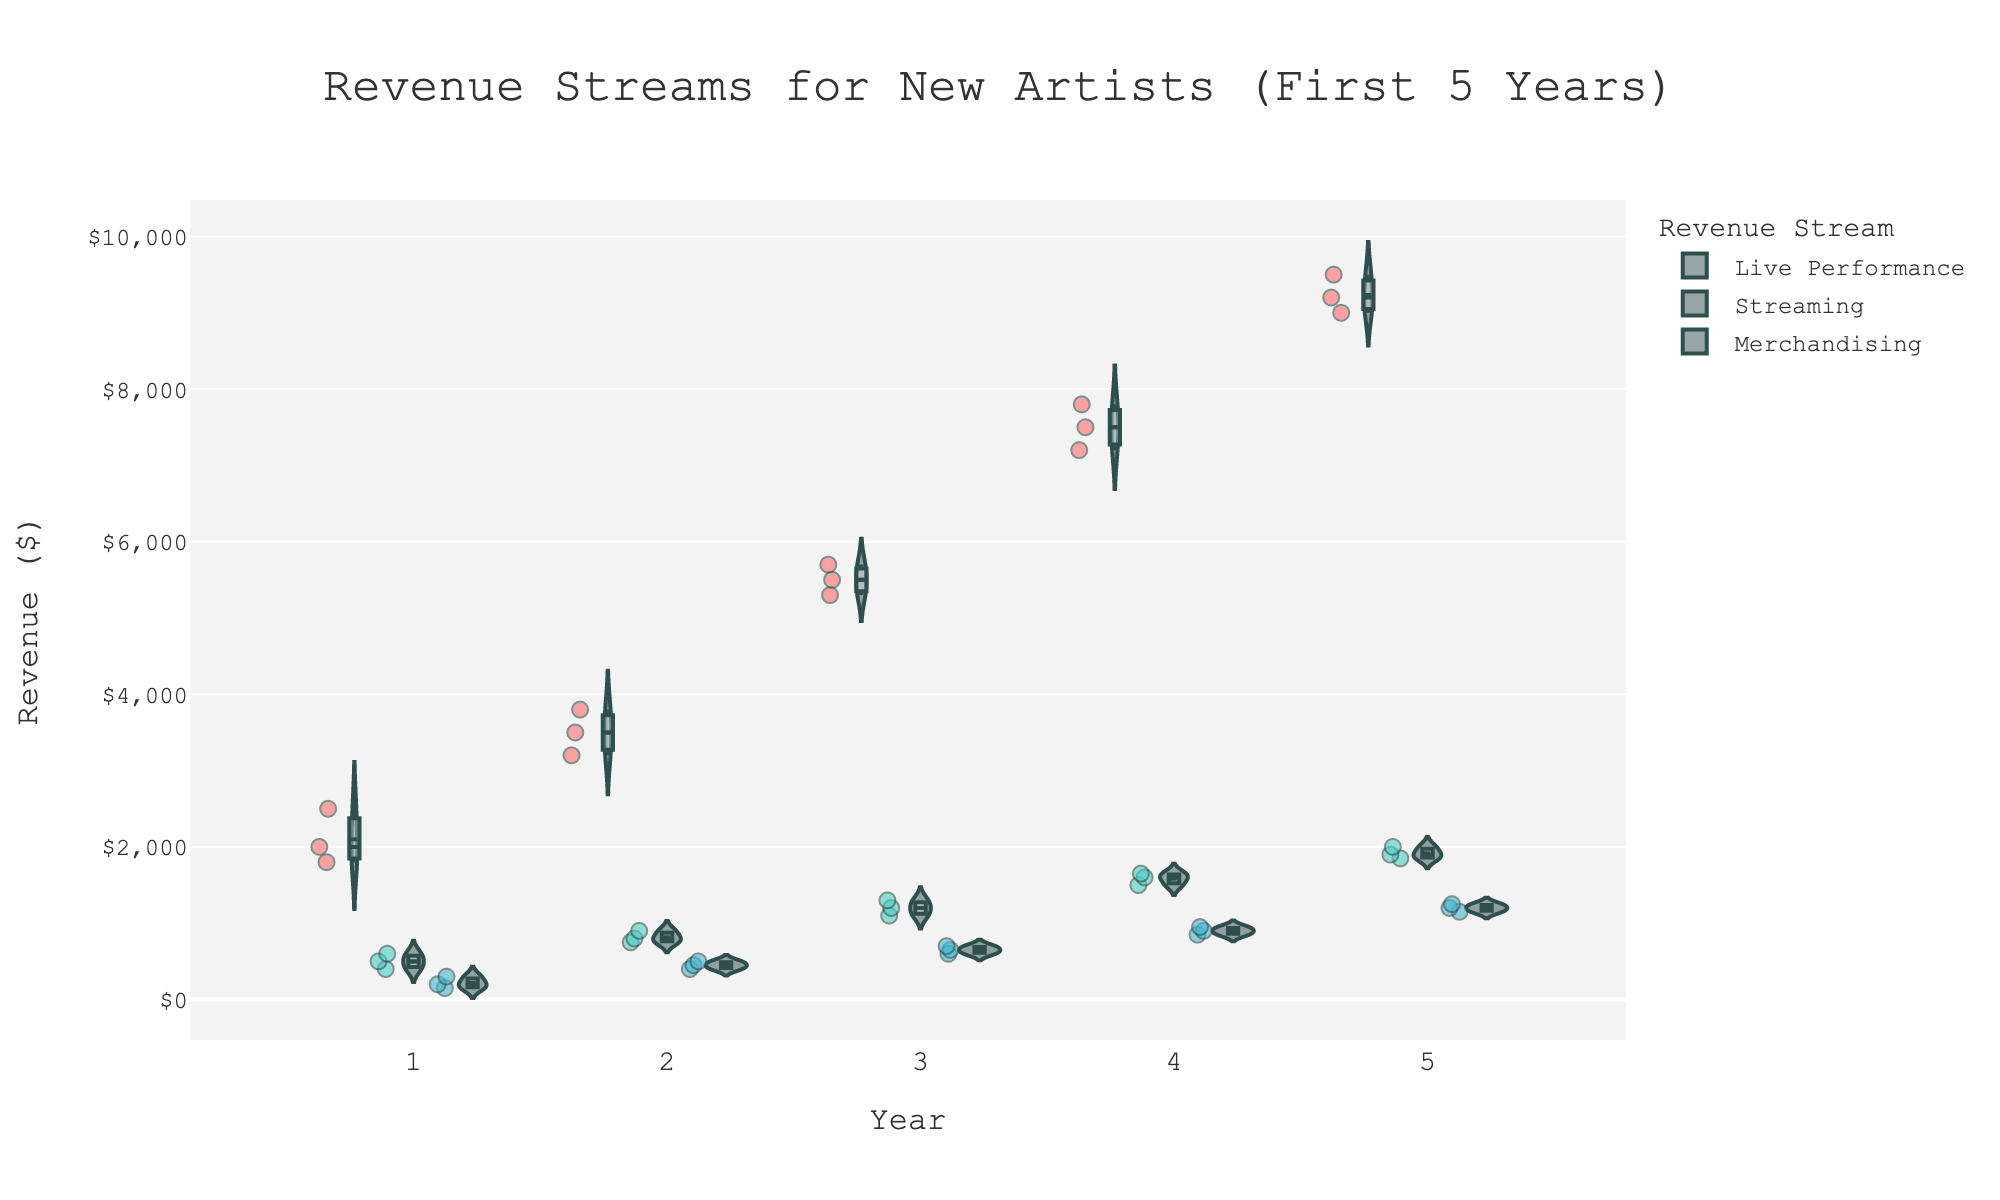What is the title of the figure? The title is located at the top of the figure, centered, and typically in a larger font size. It provides a brief description of what the chart represents.
Answer: Revenue Streams for New Artists (First 5 Years) How many revenue streams are shown in the figure? The figure uses different colors for each revenue stream, which can be identified in the legend. There are three distinct colors in the legend.
Answer: 3 Which revenue stream has the highest spread in Year 5? The spread of a revenue stream can be observed by the width of the violin plot for each category in Year 5. The widest spread indicates the highest variation in revenue.
Answer: Live Performance What is the median revenue for Live Performances in Year 3? The figure includes a box plot within each violin plot, with a horizontal line indicating the median value. For Live Performances in Year 3, find the horizontal line inside the violin plot to determine the median.
Answer: $5500 By how much did the median revenue for Streaming change from Year 1 to Year 5? First, identify the median values for Streaming in Year 1 and Year 5 using the horizontal lines in the violin plots. Then, subtract the median of Year 1 from the median of Year 5.
Answer: $1300 How does the median revenue of Merchandising compare among all five years? Observe the horizontal lines in the box plots within the violin charts for Merchandising. Compare these lines across years to see the trend in median values.
Answer: It increases each year Which year shows the highest average revenue for Live Performances? The average is represented by the centerline of the box plot within the violin. You can approximate the averages by visually inspecting the locations of these lines within the Live Performance violin plots across all years.
Answer: Year 5 Is there a visible trend in the revenue from Streaming over the five years? Inspect the violin plots for Streaming across all five years. Look for a pattern of increasing or decreasing values and the positions of medians or box plots.
Answer: Yes, the revenue trends upward Which revenue stream shows the most consistent growth? Consistency in growth can be observed by comparing the spread and median values in the violin plots over the five years for each revenue stream. The one with the most steady increase each year is the most consistent.
Answer: Merchandising What can you infer about the importance of live performances for new artists? Based on the visual spread, median values, and increase in revenue for Live Performances over the five years, assess its significance compared to other revenue streams.
Answer: They are crucial for revenue growth 